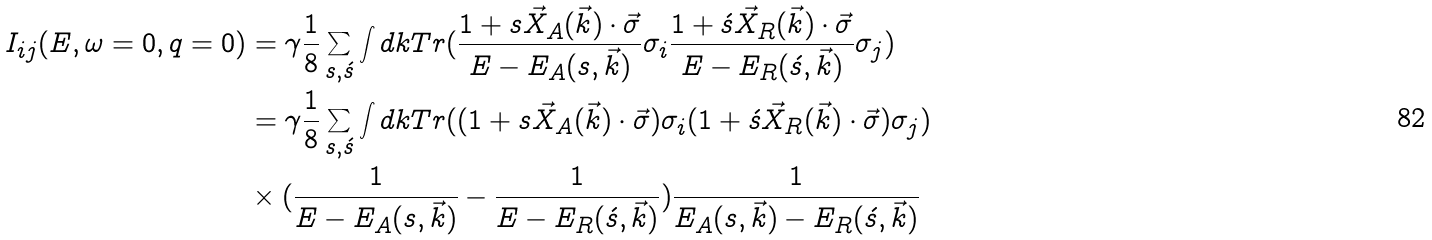Convert formula to latex. <formula><loc_0><loc_0><loc_500><loc_500>I _ { i j } ( E , \omega = 0 , q = 0 ) & = \gamma \frac { 1 } { 8 } \sum _ { s , \acute { s } } \int { d k } { T r } ( \frac { 1 + s \vec { X } _ { A } ( \vec { k } ) \cdot \vec { \sigma } } { E - E _ { A } ( s , \vec { k } ) } \sigma _ { i } \frac { 1 + \acute { s } \vec { X } _ { R } ( \vec { k } ) \cdot \vec { \sigma } } { E - E _ { R } ( \acute { s } , \vec { k } ) } \sigma _ { j } ) \\ & = \gamma \frac { 1 } { 8 } \sum _ { s , \acute { s } } \int { d k } { T r } ( ( 1 + s \vec { X } _ { A } ( \vec { k } ) \cdot \vec { \sigma } ) \sigma _ { i } ( 1 + \acute { s } \vec { X } _ { R } ( \vec { k } ) \cdot \vec { \sigma } ) \sigma _ { j } ) \\ & \times ( \frac { 1 } { E - E _ { A } ( s , \vec { k } ) } - \frac { 1 } { E - E _ { R } ( \acute { s } , \vec { k } ) } ) \frac { 1 } { E _ { A } ( s , \vec { k } ) - E _ { R } ( \acute { s } , \vec { k } ) } \\</formula> 